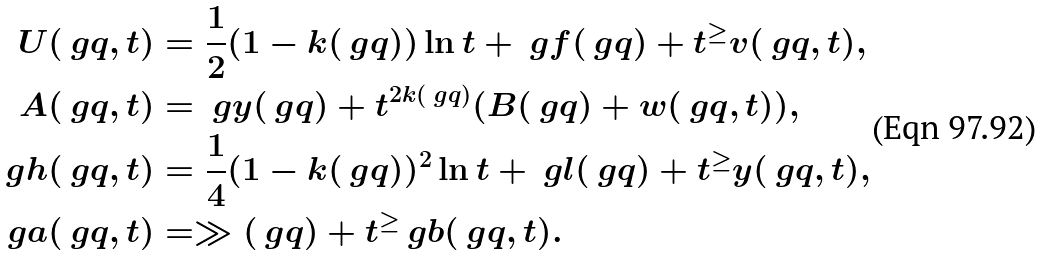Convert formula to latex. <formula><loc_0><loc_0><loc_500><loc_500>U ( \ g q , t ) & = \frac { 1 } { 2 } ( 1 - k ( \ g q ) ) \ln { t } + \ g f ( \ g q ) + t ^ { \geq } v ( \ g q , t ) , \\ A ( \ g q , t ) & = \ g y ( \ g q ) + t ^ { 2 k ( \ g q ) } ( B ( \ g q ) + w ( \ g q , t ) ) , \\ \ g h ( \ g q , t ) & = \frac { 1 } { 4 } ( 1 - k ( \ g q ) ) ^ { 2 } \ln { t } + \ g l ( \ g q ) + t ^ { \geq } y ( \ g q , t ) , \\ \ g a ( \ g q , t ) & = \gg ( \ g q ) + t ^ { \geq } \ g b ( \ g q , t ) .</formula> 